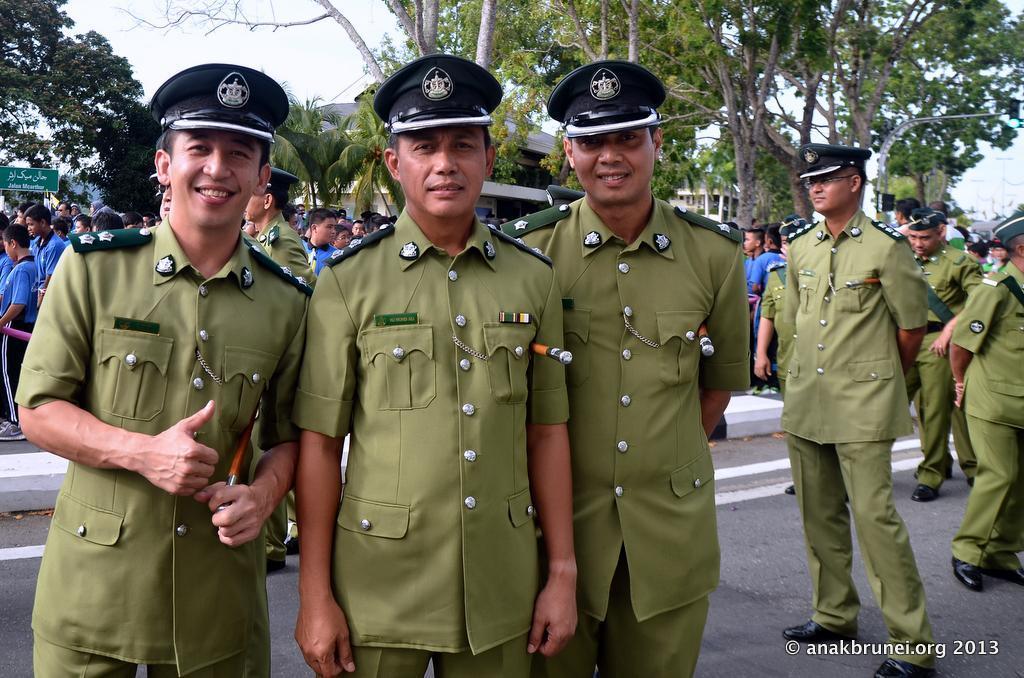Describe this image in one or two sentences. In this image we can see there are three people standing and posing for a picture, behind them there are a group of people standing, in the background there are houses, trees and a board with some text on it, at the bottom right corner of the image there is some text written. 